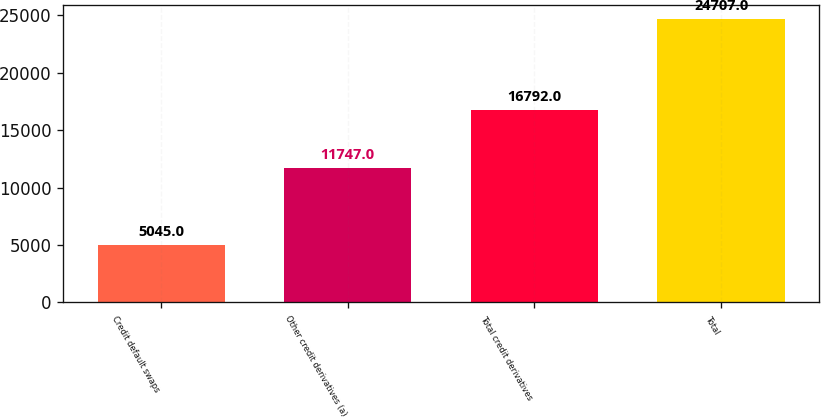Convert chart to OTSL. <chart><loc_0><loc_0><loc_500><loc_500><bar_chart><fcel>Credit default swaps<fcel>Other credit derivatives (a)<fcel>Total credit derivatives<fcel>Total<nl><fcel>5045<fcel>11747<fcel>16792<fcel>24707<nl></chart> 